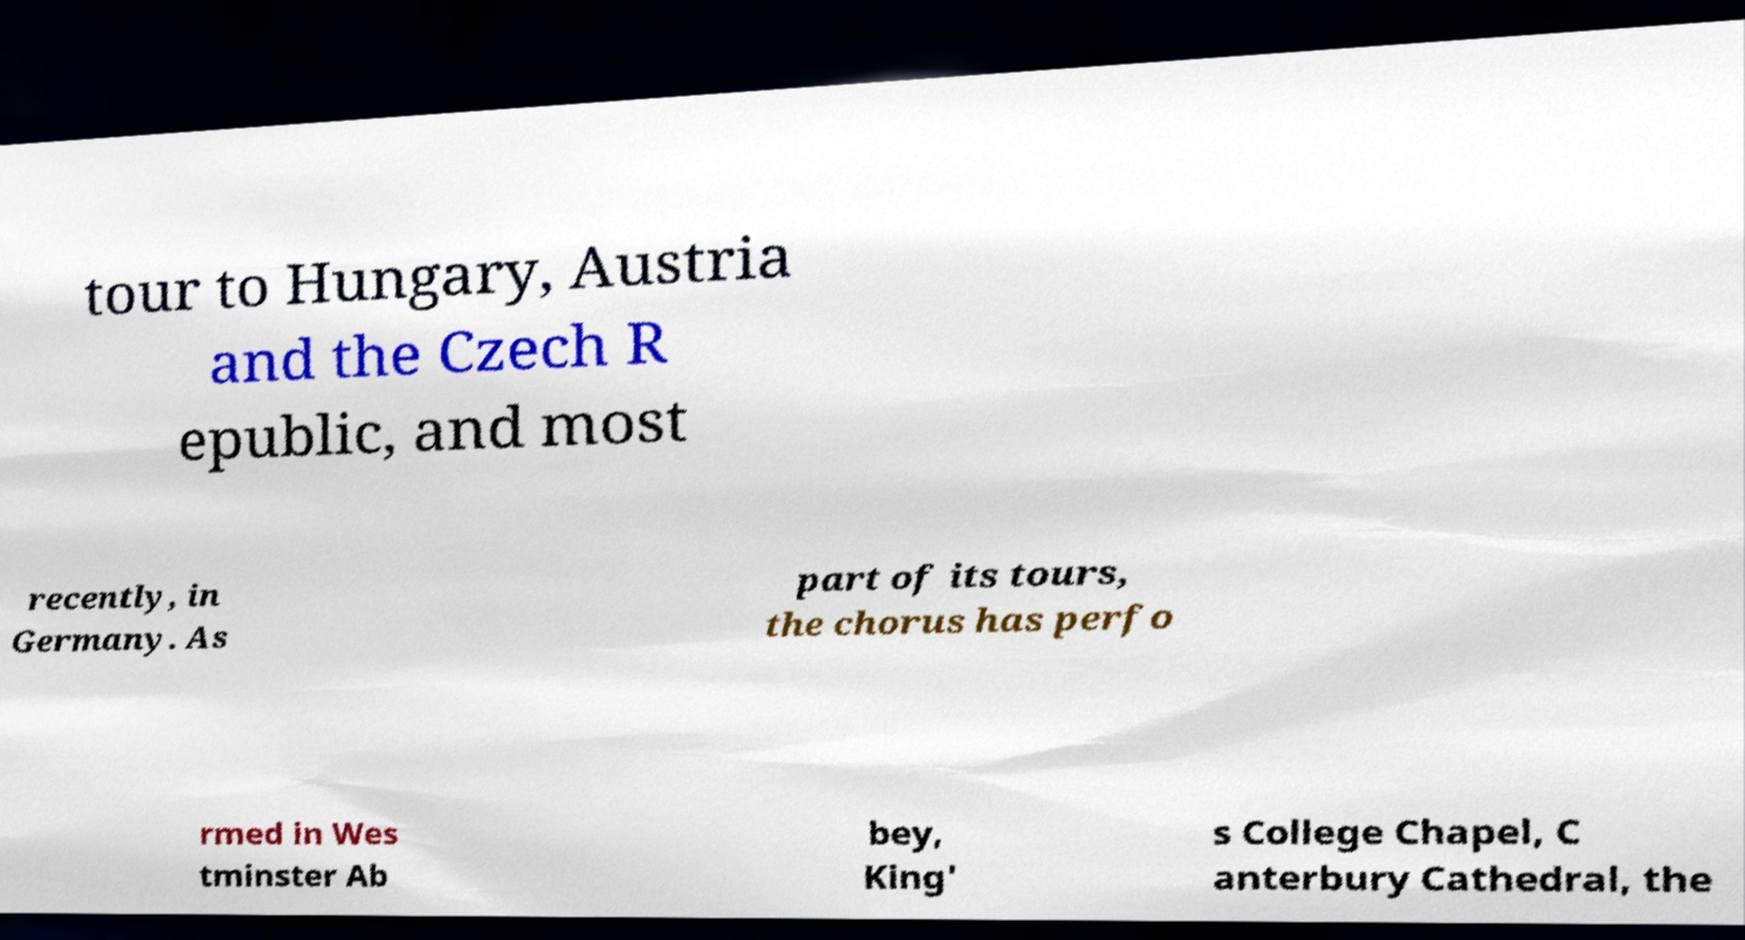Could you assist in decoding the text presented in this image and type it out clearly? tour to Hungary, Austria and the Czech R epublic, and most recently, in Germany. As part of its tours, the chorus has perfo rmed in Wes tminster Ab bey, King' s College Chapel, C anterbury Cathedral, the 